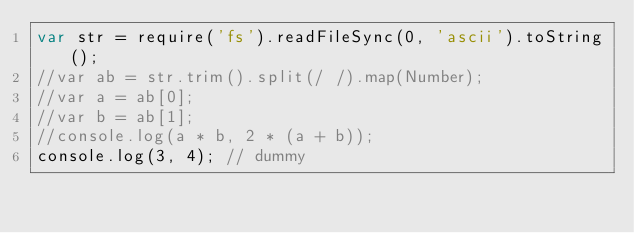<code> <loc_0><loc_0><loc_500><loc_500><_JavaScript_>var str = require('fs').readFileSync(0, 'ascii').toString();
//var ab = str.trim().split(/ /).map(Number);
//var a = ab[0];
//var b = ab[1];
//console.log(a * b, 2 * (a + b));
console.log(3, 4); // dummy</code> 